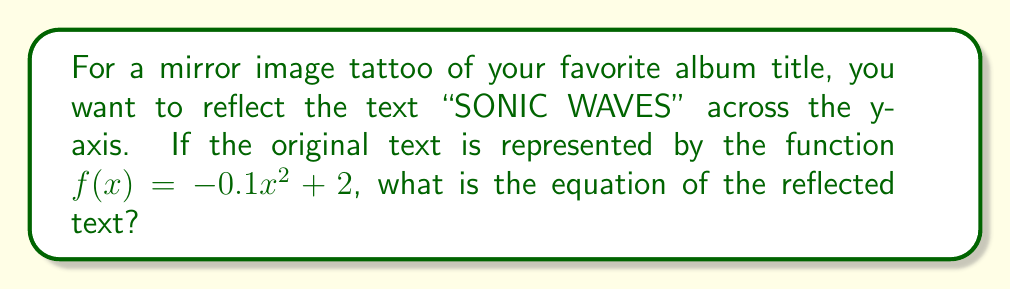Give your solution to this math problem. To reflect a function across the y-axis, we need to replace every x with -x in the original function. This is because the y-axis acts as a mirror, reversing the x-coordinates while keeping the y-coordinates the same.

Step 1: Start with the original function
$f(x) = -0.1x^2 + 2$

Step 2: Replace every x with -x
$f(-x) = -0.1(-x)^2 + 2$

Step 3: Simplify the equation
$f(-x) = -0.1(x^2) + 2$
$f(-x) = -0.1x^2 + 2$

Step 4: Rename the function to g(x) to represent the reflected function
$g(x) = -0.1x^2 + 2$

We can see that in this case, the reflected function is identical to the original function. This is because the parabola is symmetrical about the y-axis, so reflecting it across the y-axis doesn't change its shape or position.
Answer: $g(x) = -0.1x^2 + 2$ 